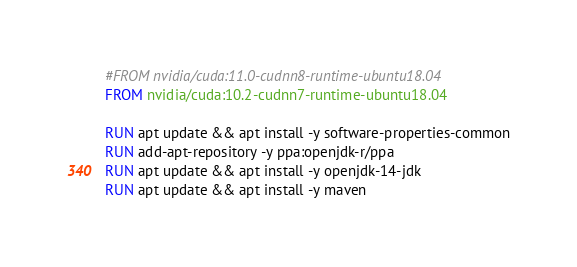<code> <loc_0><loc_0><loc_500><loc_500><_Dockerfile_>#FROM nvidia/cuda:11.0-cudnn8-runtime-ubuntu18.04
FROM nvidia/cuda:10.2-cudnn7-runtime-ubuntu18.04

RUN apt update && apt install -y software-properties-common
RUN add-apt-repository -y ppa:openjdk-r/ppa
RUN apt update && apt install -y openjdk-14-jdk
RUN apt update && apt install -y maven


</code> 